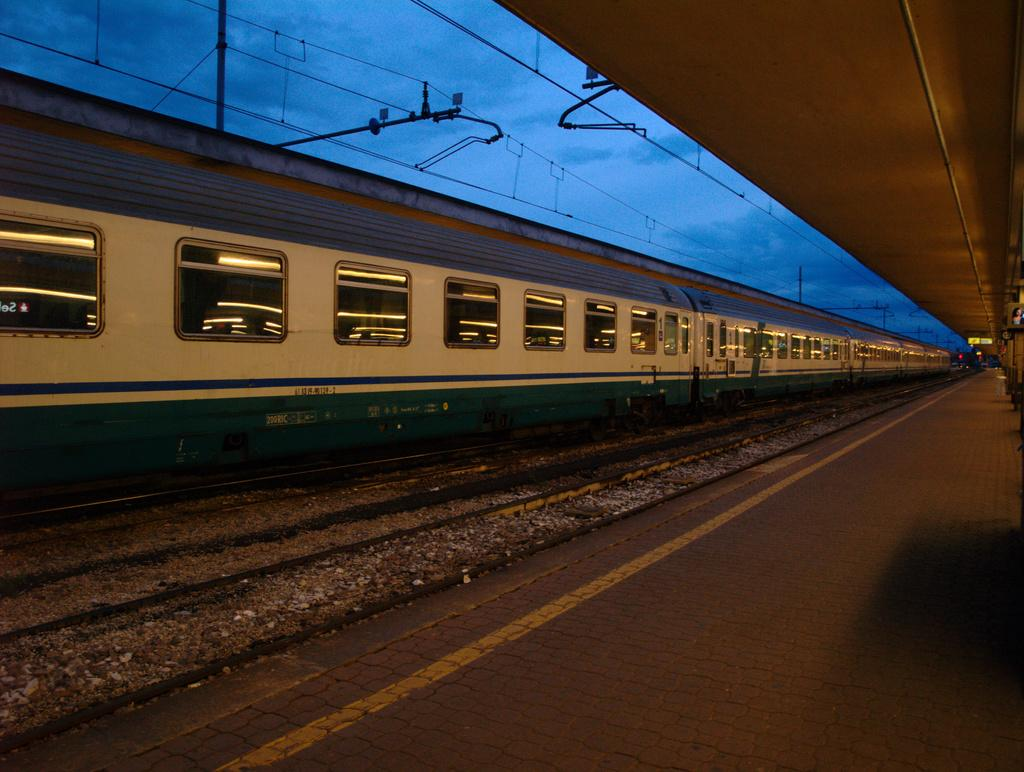What structure is located on the right side of the image? There is a platform on the right side of the image. What is on the left side of the image? There is a train on the left side of the image. What is the train positioned on? The train is on a railway track. What can be seen at the top of the image? There are poles with wires at the top of the image and the sky is visible. How many cacti are present on the platform in the image? There are no cacti present in the image; it features a platform, a train, railway tracks, poles with wires, and the sky. What type of straw is being used to drink from the train's window in the image? There is no straw present in the image; it only shows a train, railway tracks, and a platform. 